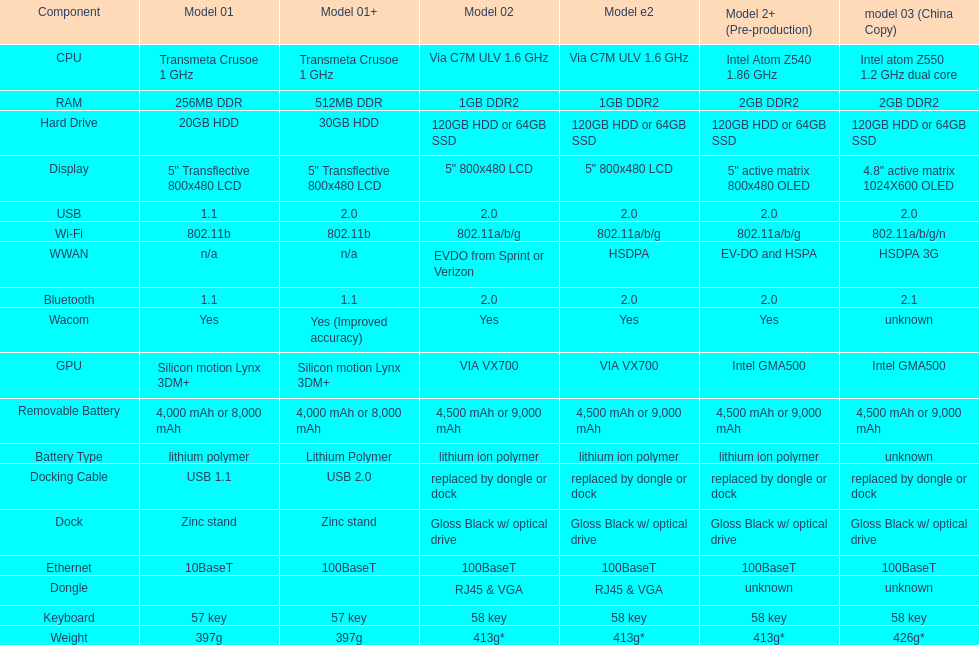Which model has the highest weight, as per the table? Model 03 (china copy). 